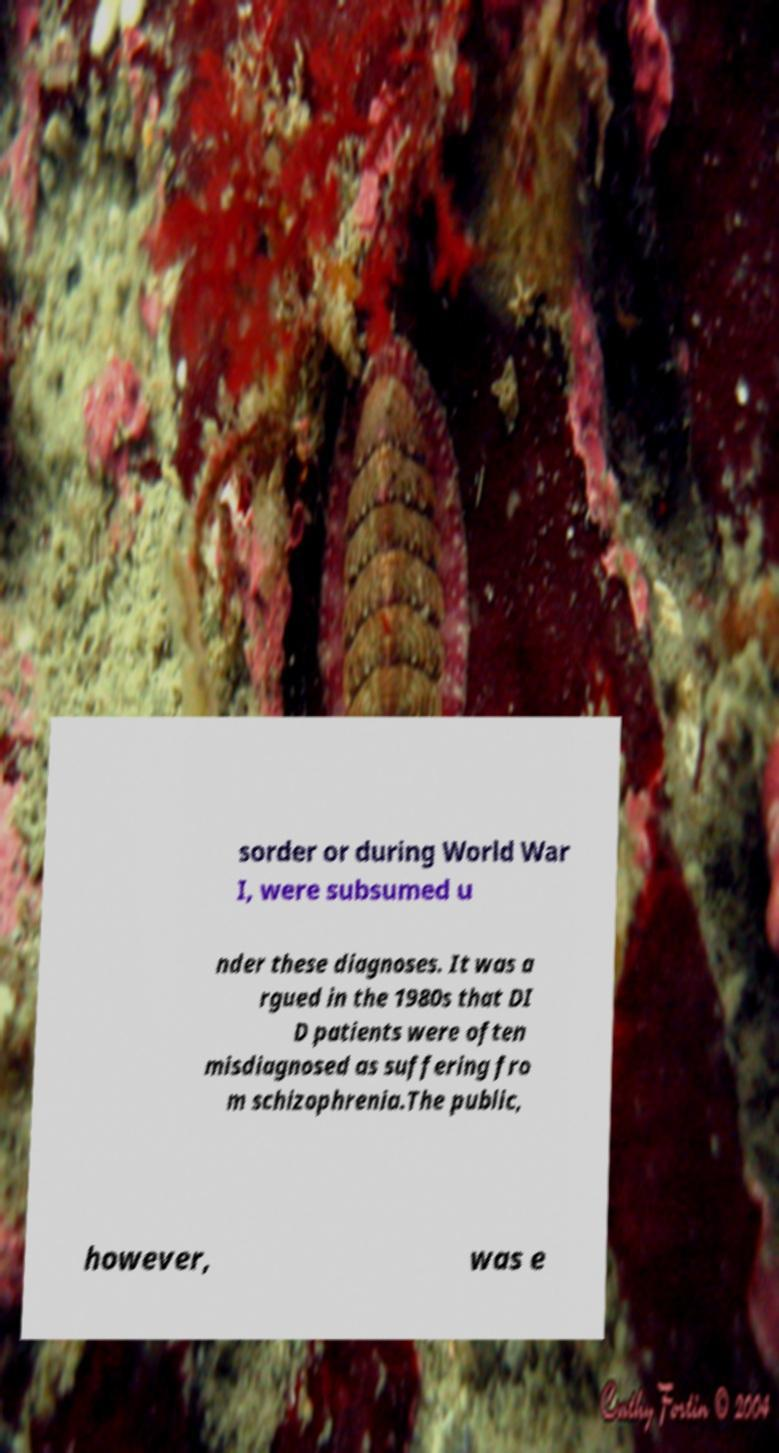Could you extract and type out the text from this image? sorder or during World War I, were subsumed u nder these diagnoses. It was a rgued in the 1980s that DI D patients were often misdiagnosed as suffering fro m schizophrenia.The public, however, was e 